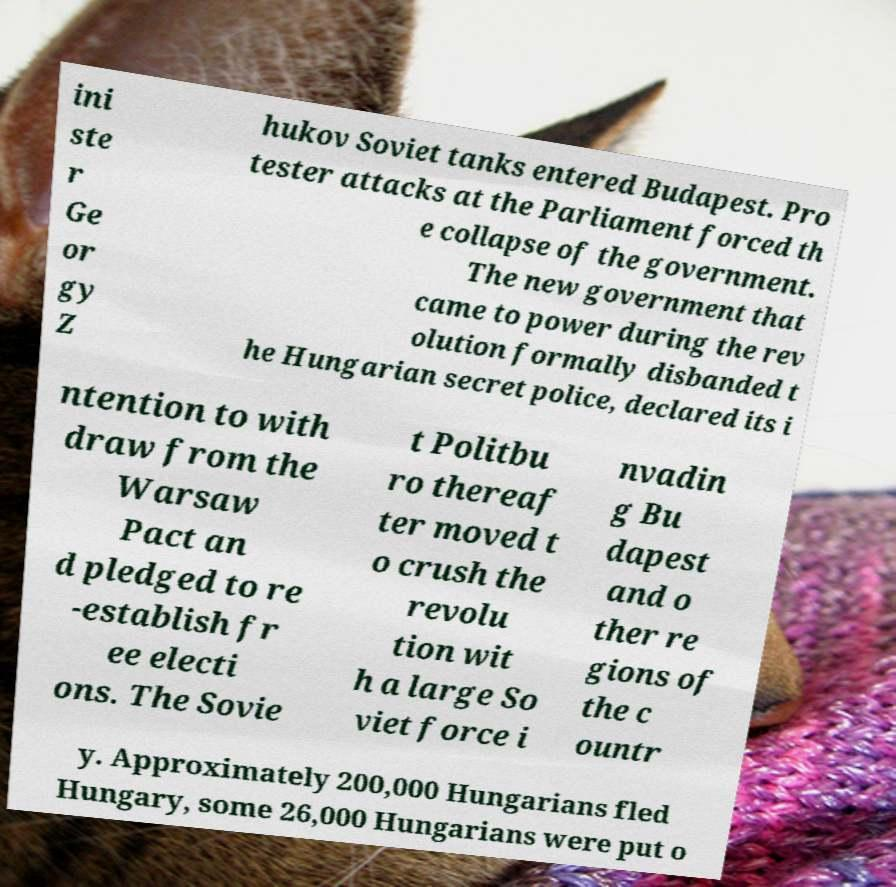For documentation purposes, I need the text within this image transcribed. Could you provide that? ini ste r Ge or gy Z hukov Soviet tanks entered Budapest. Pro tester attacks at the Parliament forced th e collapse of the government. The new government that came to power during the rev olution formally disbanded t he Hungarian secret police, declared its i ntention to with draw from the Warsaw Pact an d pledged to re -establish fr ee electi ons. The Sovie t Politbu ro thereaf ter moved t o crush the revolu tion wit h a large So viet force i nvadin g Bu dapest and o ther re gions of the c ountr y. Approximately 200,000 Hungarians fled Hungary, some 26,000 Hungarians were put o 